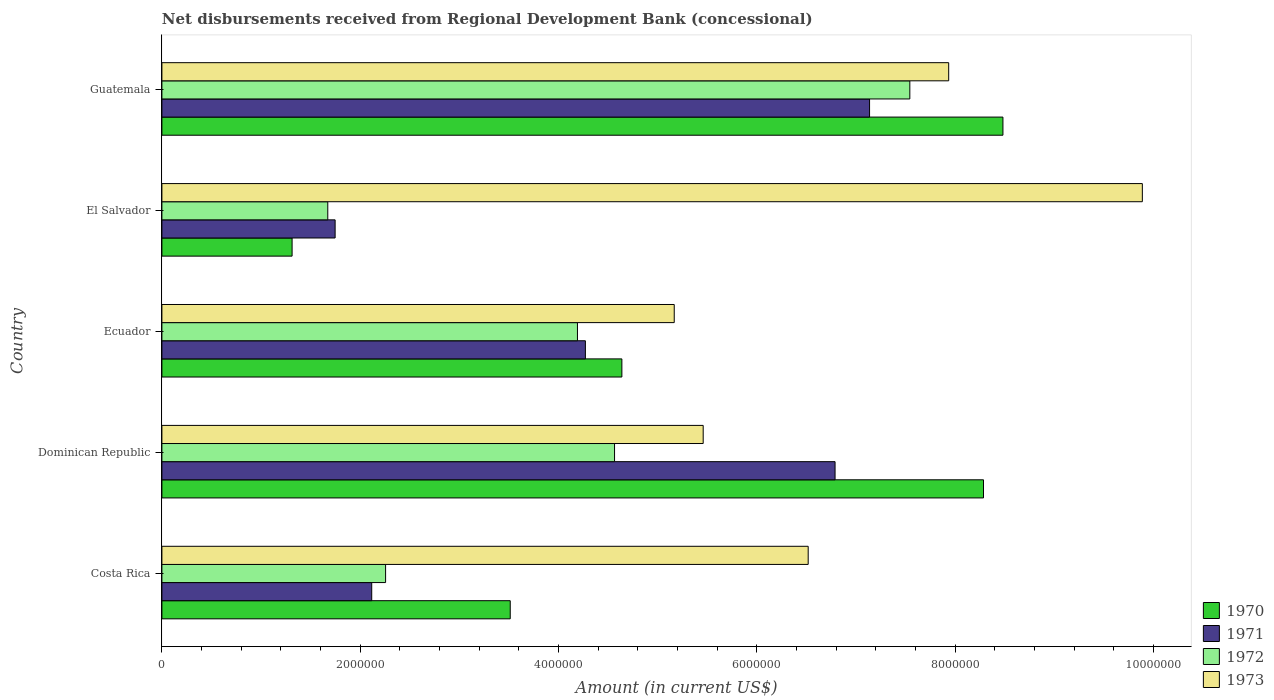Are the number of bars per tick equal to the number of legend labels?
Your response must be concise. Yes. Are the number of bars on each tick of the Y-axis equal?
Provide a short and direct response. Yes. What is the label of the 3rd group of bars from the top?
Offer a terse response. Ecuador. In how many cases, is the number of bars for a given country not equal to the number of legend labels?
Give a very brief answer. 0. What is the amount of disbursements received from Regional Development Bank in 1970 in El Salvador?
Your response must be concise. 1.31e+06. Across all countries, what is the maximum amount of disbursements received from Regional Development Bank in 1972?
Offer a very short reply. 7.54e+06. Across all countries, what is the minimum amount of disbursements received from Regional Development Bank in 1972?
Provide a short and direct response. 1.67e+06. In which country was the amount of disbursements received from Regional Development Bank in 1973 maximum?
Your answer should be very brief. El Salvador. In which country was the amount of disbursements received from Regional Development Bank in 1970 minimum?
Provide a succinct answer. El Salvador. What is the total amount of disbursements received from Regional Development Bank in 1972 in the graph?
Give a very brief answer. 2.02e+07. What is the difference between the amount of disbursements received from Regional Development Bank in 1973 in Ecuador and that in Guatemala?
Offer a very short reply. -2.77e+06. What is the difference between the amount of disbursements received from Regional Development Bank in 1973 in El Salvador and the amount of disbursements received from Regional Development Bank in 1972 in Ecuador?
Offer a very short reply. 5.70e+06. What is the average amount of disbursements received from Regional Development Bank in 1970 per country?
Your response must be concise. 5.25e+06. What is the difference between the amount of disbursements received from Regional Development Bank in 1970 and amount of disbursements received from Regional Development Bank in 1973 in Guatemala?
Give a very brief answer. 5.47e+05. In how many countries, is the amount of disbursements received from Regional Development Bank in 1973 greater than 4000000 US$?
Your answer should be very brief. 5. What is the ratio of the amount of disbursements received from Regional Development Bank in 1970 in Ecuador to that in El Salvador?
Give a very brief answer. 3.53. Is the amount of disbursements received from Regional Development Bank in 1971 in El Salvador less than that in Guatemala?
Ensure brevity in your answer.  Yes. Is the difference between the amount of disbursements received from Regional Development Bank in 1970 in Costa Rica and Dominican Republic greater than the difference between the amount of disbursements received from Regional Development Bank in 1973 in Costa Rica and Dominican Republic?
Keep it short and to the point. No. What is the difference between the highest and the second highest amount of disbursements received from Regional Development Bank in 1973?
Offer a terse response. 1.95e+06. What is the difference between the highest and the lowest amount of disbursements received from Regional Development Bank in 1971?
Offer a terse response. 5.39e+06. In how many countries, is the amount of disbursements received from Regional Development Bank in 1970 greater than the average amount of disbursements received from Regional Development Bank in 1970 taken over all countries?
Make the answer very short. 2. Is the sum of the amount of disbursements received from Regional Development Bank in 1973 in Costa Rica and Guatemala greater than the maximum amount of disbursements received from Regional Development Bank in 1972 across all countries?
Give a very brief answer. Yes. What does the 1st bar from the top in Guatemala represents?
Your answer should be compact. 1973. Are all the bars in the graph horizontal?
Ensure brevity in your answer.  Yes. How many countries are there in the graph?
Offer a terse response. 5. Does the graph contain any zero values?
Your response must be concise. No. Does the graph contain grids?
Keep it short and to the point. No. How many legend labels are there?
Provide a short and direct response. 4. What is the title of the graph?
Give a very brief answer. Net disbursements received from Regional Development Bank (concessional). What is the label or title of the X-axis?
Provide a succinct answer. Amount (in current US$). What is the Amount (in current US$) of 1970 in Costa Rica?
Provide a succinct answer. 3.51e+06. What is the Amount (in current US$) of 1971 in Costa Rica?
Your answer should be compact. 2.12e+06. What is the Amount (in current US$) of 1972 in Costa Rica?
Your answer should be very brief. 2.26e+06. What is the Amount (in current US$) of 1973 in Costa Rica?
Provide a short and direct response. 6.52e+06. What is the Amount (in current US$) in 1970 in Dominican Republic?
Offer a terse response. 8.29e+06. What is the Amount (in current US$) in 1971 in Dominican Republic?
Make the answer very short. 6.79e+06. What is the Amount (in current US$) in 1972 in Dominican Republic?
Give a very brief answer. 4.56e+06. What is the Amount (in current US$) of 1973 in Dominican Republic?
Make the answer very short. 5.46e+06. What is the Amount (in current US$) of 1970 in Ecuador?
Provide a succinct answer. 4.64e+06. What is the Amount (in current US$) in 1971 in Ecuador?
Make the answer very short. 4.27e+06. What is the Amount (in current US$) in 1972 in Ecuador?
Your answer should be compact. 4.19e+06. What is the Amount (in current US$) in 1973 in Ecuador?
Ensure brevity in your answer.  5.17e+06. What is the Amount (in current US$) in 1970 in El Salvador?
Your answer should be compact. 1.31e+06. What is the Amount (in current US$) of 1971 in El Salvador?
Offer a terse response. 1.75e+06. What is the Amount (in current US$) in 1972 in El Salvador?
Offer a terse response. 1.67e+06. What is the Amount (in current US$) of 1973 in El Salvador?
Your answer should be compact. 9.89e+06. What is the Amount (in current US$) in 1970 in Guatemala?
Ensure brevity in your answer.  8.48e+06. What is the Amount (in current US$) of 1971 in Guatemala?
Ensure brevity in your answer.  7.14e+06. What is the Amount (in current US$) in 1972 in Guatemala?
Your response must be concise. 7.54e+06. What is the Amount (in current US$) in 1973 in Guatemala?
Ensure brevity in your answer.  7.94e+06. Across all countries, what is the maximum Amount (in current US$) of 1970?
Provide a short and direct response. 8.48e+06. Across all countries, what is the maximum Amount (in current US$) in 1971?
Your answer should be very brief. 7.14e+06. Across all countries, what is the maximum Amount (in current US$) of 1972?
Ensure brevity in your answer.  7.54e+06. Across all countries, what is the maximum Amount (in current US$) of 1973?
Your answer should be very brief. 9.89e+06. Across all countries, what is the minimum Amount (in current US$) in 1970?
Your answer should be compact. 1.31e+06. Across all countries, what is the minimum Amount (in current US$) in 1971?
Provide a succinct answer. 1.75e+06. Across all countries, what is the minimum Amount (in current US$) in 1972?
Make the answer very short. 1.67e+06. Across all countries, what is the minimum Amount (in current US$) of 1973?
Provide a short and direct response. 5.17e+06. What is the total Amount (in current US$) of 1970 in the graph?
Provide a short and direct response. 2.62e+07. What is the total Amount (in current US$) of 1971 in the graph?
Keep it short and to the point. 2.21e+07. What is the total Amount (in current US$) of 1972 in the graph?
Your answer should be very brief. 2.02e+07. What is the total Amount (in current US$) in 1973 in the graph?
Offer a very short reply. 3.50e+07. What is the difference between the Amount (in current US$) of 1970 in Costa Rica and that in Dominican Republic?
Ensure brevity in your answer.  -4.77e+06. What is the difference between the Amount (in current US$) in 1971 in Costa Rica and that in Dominican Republic?
Your answer should be compact. -4.67e+06. What is the difference between the Amount (in current US$) of 1972 in Costa Rica and that in Dominican Republic?
Offer a terse response. -2.31e+06. What is the difference between the Amount (in current US$) in 1973 in Costa Rica and that in Dominican Republic?
Offer a very short reply. 1.06e+06. What is the difference between the Amount (in current US$) of 1970 in Costa Rica and that in Ecuador?
Your response must be concise. -1.13e+06. What is the difference between the Amount (in current US$) in 1971 in Costa Rica and that in Ecuador?
Your answer should be very brief. -2.16e+06. What is the difference between the Amount (in current US$) of 1972 in Costa Rica and that in Ecuador?
Make the answer very short. -1.94e+06. What is the difference between the Amount (in current US$) of 1973 in Costa Rica and that in Ecuador?
Keep it short and to the point. 1.35e+06. What is the difference between the Amount (in current US$) of 1970 in Costa Rica and that in El Salvador?
Offer a very short reply. 2.20e+06. What is the difference between the Amount (in current US$) in 1971 in Costa Rica and that in El Salvador?
Your answer should be very brief. 3.69e+05. What is the difference between the Amount (in current US$) in 1972 in Costa Rica and that in El Salvador?
Your answer should be compact. 5.83e+05. What is the difference between the Amount (in current US$) in 1973 in Costa Rica and that in El Salvador?
Provide a succinct answer. -3.37e+06. What is the difference between the Amount (in current US$) of 1970 in Costa Rica and that in Guatemala?
Your response must be concise. -4.97e+06. What is the difference between the Amount (in current US$) in 1971 in Costa Rica and that in Guatemala?
Your answer should be very brief. -5.02e+06. What is the difference between the Amount (in current US$) of 1972 in Costa Rica and that in Guatemala?
Offer a terse response. -5.29e+06. What is the difference between the Amount (in current US$) in 1973 in Costa Rica and that in Guatemala?
Offer a very short reply. -1.42e+06. What is the difference between the Amount (in current US$) of 1970 in Dominican Republic and that in Ecuador?
Make the answer very short. 3.65e+06. What is the difference between the Amount (in current US$) of 1971 in Dominican Republic and that in Ecuador?
Ensure brevity in your answer.  2.52e+06. What is the difference between the Amount (in current US$) of 1972 in Dominican Republic and that in Ecuador?
Provide a succinct answer. 3.74e+05. What is the difference between the Amount (in current US$) of 1973 in Dominican Republic and that in Ecuador?
Provide a succinct answer. 2.92e+05. What is the difference between the Amount (in current US$) in 1970 in Dominican Republic and that in El Salvador?
Keep it short and to the point. 6.97e+06. What is the difference between the Amount (in current US$) in 1971 in Dominican Republic and that in El Salvador?
Your answer should be compact. 5.04e+06. What is the difference between the Amount (in current US$) in 1972 in Dominican Republic and that in El Salvador?
Make the answer very short. 2.89e+06. What is the difference between the Amount (in current US$) in 1973 in Dominican Republic and that in El Salvador?
Your answer should be compact. -4.43e+06. What is the difference between the Amount (in current US$) of 1970 in Dominican Republic and that in Guatemala?
Give a very brief answer. -1.96e+05. What is the difference between the Amount (in current US$) of 1971 in Dominican Republic and that in Guatemala?
Make the answer very short. -3.48e+05. What is the difference between the Amount (in current US$) in 1972 in Dominican Republic and that in Guatemala?
Offer a terse response. -2.98e+06. What is the difference between the Amount (in current US$) in 1973 in Dominican Republic and that in Guatemala?
Ensure brevity in your answer.  -2.48e+06. What is the difference between the Amount (in current US$) of 1970 in Ecuador and that in El Salvador?
Keep it short and to the point. 3.33e+06. What is the difference between the Amount (in current US$) in 1971 in Ecuador and that in El Salvador?
Offer a very short reply. 2.52e+06. What is the difference between the Amount (in current US$) in 1972 in Ecuador and that in El Salvador?
Make the answer very short. 2.52e+06. What is the difference between the Amount (in current US$) in 1973 in Ecuador and that in El Salvador?
Provide a succinct answer. -4.72e+06. What is the difference between the Amount (in current US$) of 1970 in Ecuador and that in Guatemala?
Your answer should be very brief. -3.84e+06. What is the difference between the Amount (in current US$) of 1971 in Ecuador and that in Guatemala?
Provide a succinct answer. -2.87e+06. What is the difference between the Amount (in current US$) of 1972 in Ecuador and that in Guatemala?
Ensure brevity in your answer.  -3.35e+06. What is the difference between the Amount (in current US$) of 1973 in Ecuador and that in Guatemala?
Ensure brevity in your answer.  -2.77e+06. What is the difference between the Amount (in current US$) of 1970 in El Salvador and that in Guatemala?
Provide a short and direct response. -7.17e+06. What is the difference between the Amount (in current US$) in 1971 in El Salvador and that in Guatemala?
Your answer should be compact. -5.39e+06. What is the difference between the Amount (in current US$) in 1972 in El Salvador and that in Guatemala?
Offer a terse response. -5.87e+06. What is the difference between the Amount (in current US$) of 1973 in El Salvador and that in Guatemala?
Provide a succinct answer. 1.95e+06. What is the difference between the Amount (in current US$) of 1970 in Costa Rica and the Amount (in current US$) of 1971 in Dominican Republic?
Provide a succinct answer. -3.28e+06. What is the difference between the Amount (in current US$) of 1970 in Costa Rica and the Amount (in current US$) of 1972 in Dominican Republic?
Make the answer very short. -1.05e+06. What is the difference between the Amount (in current US$) in 1970 in Costa Rica and the Amount (in current US$) in 1973 in Dominican Republic?
Keep it short and to the point. -1.95e+06. What is the difference between the Amount (in current US$) in 1971 in Costa Rica and the Amount (in current US$) in 1972 in Dominican Republic?
Make the answer very short. -2.45e+06. What is the difference between the Amount (in current US$) in 1971 in Costa Rica and the Amount (in current US$) in 1973 in Dominican Republic?
Provide a succinct answer. -3.34e+06. What is the difference between the Amount (in current US$) in 1972 in Costa Rica and the Amount (in current US$) in 1973 in Dominican Republic?
Your answer should be compact. -3.20e+06. What is the difference between the Amount (in current US$) of 1970 in Costa Rica and the Amount (in current US$) of 1971 in Ecuador?
Your response must be concise. -7.58e+05. What is the difference between the Amount (in current US$) in 1970 in Costa Rica and the Amount (in current US$) in 1972 in Ecuador?
Offer a terse response. -6.78e+05. What is the difference between the Amount (in current US$) in 1970 in Costa Rica and the Amount (in current US$) in 1973 in Ecuador?
Your answer should be compact. -1.65e+06. What is the difference between the Amount (in current US$) of 1971 in Costa Rica and the Amount (in current US$) of 1972 in Ecuador?
Your response must be concise. -2.08e+06. What is the difference between the Amount (in current US$) in 1971 in Costa Rica and the Amount (in current US$) in 1973 in Ecuador?
Offer a very short reply. -3.05e+06. What is the difference between the Amount (in current US$) of 1972 in Costa Rica and the Amount (in current US$) of 1973 in Ecuador?
Provide a succinct answer. -2.91e+06. What is the difference between the Amount (in current US$) of 1970 in Costa Rica and the Amount (in current US$) of 1971 in El Salvador?
Provide a succinct answer. 1.77e+06. What is the difference between the Amount (in current US$) of 1970 in Costa Rica and the Amount (in current US$) of 1972 in El Salvador?
Provide a short and direct response. 1.84e+06. What is the difference between the Amount (in current US$) of 1970 in Costa Rica and the Amount (in current US$) of 1973 in El Salvador?
Keep it short and to the point. -6.38e+06. What is the difference between the Amount (in current US$) in 1971 in Costa Rica and the Amount (in current US$) in 1972 in El Salvador?
Ensure brevity in your answer.  4.43e+05. What is the difference between the Amount (in current US$) in 1971 in Costa Rica and the Amount (in current US$) in 1973 in El Salvador?
Your response must be concise. -7.77e+06. What is the difference between the Amount (in current US$) in 1972 in Costa Rica and the Amount (in current US$) in 1973 in El Salvador?
Give a very brief answer. -7.63e+06. What is the difference between the Amount (in current US$) in 1970 in Costa Rica and the Amount (in current US$) in 1971 in Guatemala?
Offer a very short reply. -3.62e+06. What is the difference between the Amount (in current US$) of 1970 in Costa Rica and the Amount (in current US$) of 1972 in Guatemala?
Offer a terse response. -4.03e+06. What is the difference between the Amount (in current US$) of 1970 in Costa Rica and the Amount (in current US$) of 1973 in Guatemala?
Your answer should be compact. -4.42e+06. What is the difference between the Amount (in current US$) of 1971 in Costa Rica and the Amount (in current US$) of 1972 in Guatemala?
Keep it short and to the point. -5.43e+06. What is the difference between the Amount (in current US$) in 1971 in Costa Rica and the Amount (in current US$) in 1973 in Guatemala?
Your answer should be compact. -5.82e+06. What is the difference between the Amount (in current US$) in 1972 in Costa Rica and the Amount (in current US$) in 1973 in Guatemala?
Offer a very short reply. -5.68e+06. What is the difference between the Amount (in current US$) of 1970 in Dominican Republic and the Amount (in current US$) of 1971 in Ecuador?
Provide a succinct answer. 4.02e+06. What is the difference between the Amount (in current US$) in 1970 in Dominican Republic and the Amount (in current US$) in 1972 in Ecuador?
Make the answer very short. 4.10e+06. What is the difference between the Amount (in current US$) in 1970 in Dominican Republic and the Amount (in current US$) in 1973 in Ecuador?
Offer a terse response. 3.12e+06. What is the difference between the Amount (in current US$) in 1971 in Dominican Republic and the Amount (in current US$) in 1972 in Ecuador?
Keep it short and to the point. 2.60e+06. What is the difference between the Amount (in current US$) of 1971 in Dominican Republic and the Amount (in current US$) of 1973 in Ecuador?
Offer a terse response. 1.62e+06. What is the difference between the Amount (in current US$) of 1972 in Dominican Republic and the Amount (in current US$) of 1973 in Ecuador?
Ensure brevity in your answer.  -6.02e+05. What is the difference between the Amount (in current US$) of 1970 in Dominican Republic and the Amount (in current US$) of 1971 in El Salvador?
Make the answer very short. 6.54e+06. What is the difference between the Amount (in current US$) in 1970 in Dominican Republic and the Amount (in current US$) in 1972 in El Salvador?
Provide a short and direct response. 6.61e+06. What is the difference between the Amount (in current US$) of 1970 in Dominican Republic and the Amount (in current US$) of 1973 in El Salvador?
Your response must be concise. -1.60e+06. What is the difference between the Amount (in current US$) of 1971 in Dominican Republic and the Amount (in current US$) of 1972 in El Salvador?
Keep it short and to the point. 5.12e+06. What is the difference between the Amount (in current US$) of 1971 in Dominican Republic and the Amount (in current US$) of 1973 in El Salvador?
Give a very brief answer. -3.10e+06. What is the difference between the Amount (in current US$) in 1972 in Dominican Republic and the Amount (in current US$) in 1973 in El Salvador?
Give a very brief answer. -5.32e+06. What is the difference between the Amount (in current US$) of 1970 in Dominican Republic and the Amount (in current US$) of 1971 in Guatemala?
Give a very brief answer. 1.15e+06. What is the difference between the Amount (in current US$) in 1970 in Dominican Republic and the Amount (in current US$) in 1972 in Guatemala?
Keep it short and to the point. 7.43e+05. What is the difference between the Amount (in current US$) in 1970 in Dominican Republic and the Amount (in current US$) in 1973 in Guatemala?
Offer a terse response. 3.51e+05. What is the difference between the Amount (in current US$) in 1971 in Dominican Republic and the Amount (in current US$) in 1972 in Guatemala?
Make the answer very short. -7.54e+05. What is the difference between the Amount (in current US$) in 1971 in Dominican Republic and the Amount (in current US$) in 1973 in Guatemala?
Offer a terse response. -1.15e+06. What is the difference between the Amount (in current US$) in 1972 in Dominican Republic and the Amount (in current US$) in 1973 in Guatemala?
Your answer should be compact. -3.37e+06. What is the difference between the Amount (in current US$) of 1970 in Ecuador and the Amount (in current US$) of 1971 in El Salvador?
Your response must be concise. 2.89e+06. What is the difference between the Amount (in current US$) of 1970 in Ecuador and the Amount (in current US$) of 1972 in El Salvador?
Your response must be concise. 2.97e+06. What is the difference between the Amount (in current US$) of 1970 in Ecuador and the Amount (in current US$) of 1973 in El Salvador?
Offer a terse response. -5.25e+06. What is the difference between the Amount (in current US$) in 1971 in Ecuador and the Amount (in current US$) in 1972 in El Salvador?
Keep it short and to the point. 2.60e+06. What is the difference between the Amount (in current US$) in 1971 in Ecuador and the Amount (in current US$) in 1973 in El Salvador?
Your response must be concise. -5.62e+06. What is the difference between the Amount (in current US$) of 1972 in Ecuador and the Amount (in current US$) of 1973 in El Salvador?
Your answer should be compact. -5.70e+06. What is the difference between the Amount (in current US$) of 1970 in Ecuador and the Amount (in current US$) of 1971 in Guatemala?
Make the answer very short. -2.50e+06. What is the difference between the Amount (in current US$) of 1970 in Ecuador and the Amount (in current US$) of 1972 in Guatemala?
Keep it short and to the point. -2.90e+06. What is the difference between the Amount (in current US$) of 1970 in Ecuador and the Amount (in current US$) of 1973 in Guatemala?
Provide a short and direct response. -3.30e+06. What is the difference between the Amount (in current US$) in 1971 in Ecuador and the Amount (in current US$) in 1972 in Guatemala?
Your answer should be compact. -3.27e+06. What is the difference between the Amount (in current US$) in 1971 in Ecuador and the Amount (in current US$) in 1973 in Guatemala?
Give a very brief answer. -3.66e+06. What is the difference between the Amount (in current US$) in 1972 in Ecuador and the Amount (in current US$) in 1973 in Guatemala?
Your answer should be very brief. -3.74e+06. What is the difference between the Amount (in current US$) of 1970 in El Salvador and the Amount (in current US$) of 1971 in Guatemala?
Offer a terse response. -5.82e+06. What is the difference between the Amount (in current US$) of 1970 in El Salvador and the Amount (in current US$) of 1972 in Guatemala?
Your answer should be compact. -6.23e+06. What is the difference between the Amount (in current US$) in 1970 in El Salvador and the Amount (in current US$) in 1973 in Guatemala?
Your response must be concise. -6.62e+06. What is the difference between the Amount (in current US$) of 1971 in El Salvador and the Amount (in current US$) of 1972 in Guatemala?
Your response must be concise. -5.80e+06. What is the difference between the Amount (in current US$) of 1971 in El Salvador and the Amount (in current US$) of 1973 in Guatemala?
Make the answer very short. -6.19e+06. What is the difference between the Amount (in current US$) in 1972 in El Salvador and the Amount (in current US$) in 1973 in Guatemala?
Provide a short and direct response. -6.26e+06. What is the average Amount (in current US$) of 1970 per country?
Provide a succinct answer. 5.25e+06. What is the average Amount (in current US$) of 1971 per country?
Your answer should be compact. 4.41e+06. What is the average Amount (in current US$) in 1972 per country?
Offer a very short reply. 4.05e+06. What is the average Amount (in current US$) of 1973 per country?
Keep it short and to the point. 6.99e+06. What is the difference between the Amount (in current US$) of 1970 and Amount (in current US$) of 1971 in Costa Rica?
Provide a short and direct response. 1.40e+06. What is the difference between the Amount (in current US$) of 1970 and Amount (in current US$) of 1972 in Costa Rica?
Keep it short and to the point. 1.26e+06. What is the difference between the Amount (in current US$) of 1970 and Amount (in current US$) of 1973 in Costa Rica?
Your response must be concise. -3.00e+06. What is the difference between the Amount (in current US$) in 1971 and Amount (in current US$) in 1972 in Costa Rica?
Your response must be concise. -1.40e+05. What is the difference between the Amount (in current US$) of 1971 and Amount (in current US$) of 1973 in Costa Rica?
Keep it short and to the point. -4.40e+06. What is the difference between the Amount (in current US$) in 1972 and Amount (in current US$) in 1973 in Costa Rica?
Offer a very short reply. -4.26e+06. What is the difference between the Amount (in current US$) in 1970 and Amount (in current US$) in 1971 in Dominican Republic?
Your answer should be very brief. 1.50e+06. What is the difference between the Amount (in current US$) of 1970 and Amount (in current US$) of 1972 in Dominican Republic?
Give a very brief answer. 3.72e+06. What is the difference between the Amount (in current US$) of 1970 and Amount (in current US$) of 1973 in Dominican Republic?
Make the answer very short. 2.83e+06. What is the difference between the Amount (in current US$) in 1971 and Amount (in current US$) in 1972 in Dominican Republic?
Offer a very short reply. 2.22e+06. What is the difference between the Amount (in current US$) of 1971 and Amount (in current US$) of 1973 in Dominican Republic?
Keep it short and to the point. 1.33e+06. What is the difference between the Amount (in current US$) in 1972 and Amount (in current US$) in 1973 in Dominican Republic?
Your answer should be compact. -8.94e+05. What is the difference between the Amount (in current US$) in 1970 and Amount (in current US$) in 1971 in Ecuador?
Keep it short and to the point. 3.68e+05. What is the difference between the Amount (in current US$) of 1970 and Amount (in current US$) of 1972 in Ecuador?
Offer a terse response. 4.48e+05. What is the difference between the Amount (in current US$) of 1970 and Amount (in current US$) of 1973 in Ecuador?
Give a very brief answer. -5.28e+05. What is the difference between the Amount (in current US$) in 1971 and Amount (in current US$) in 1973 in Ecuador?
Offer a very short reply. -8.96e+05. What is the difference between the Amount (in current US$) of 1972 and Amount (in current US$) of 1973 in Ecuador?
Offer a very short reply. -9.76e+05. What is the difference between the Amount (in current US$) in 1970 and Amount (in current US$) in 1971 in El Salvador?
Give a very brief answer. -4.34e+05. What is the difference between the Amount (in current US$) of 1970 and Amount (in current US$) of 1972 in El Salvador?
Offer a very short reply. -3.60e+05. What is the difference between the Amount (in current US$) in 1970 and Amount (in current US$) in 1973 in El Salvador?
Make the answer very short. -8.58e+06. What is the difference between the Amount (in current US$) of 1971 and Amount (in current US$) of 1972 in El Salvador?
Make the answer very short. 7.40e+04. What is the difference between the Amount (in current US$) in 1971 and Amount (in current US$) in 1973 in El Salvador?
Offer a terse response. -8.14e+06. What is the difference between the Amount (in current US$) of 1972 and Amount (in current US$) of 1973 in El Salvador?
Ensure brevity in your answer.  -8.22e+06. What is the difference between the Amount (in current US$) of 1970 and Amount (in current US$) of 1971 in Guatemala?
Ensure brevity in your answer.  1.34e+06. What is the difference between the Amount (in current US$) in 1970 and Amount (in current US$) in 1972 in Guatemala?
Offer a very short reply. 9.39e+05. What is the difference between the Amount (in current US$) in 1970 and Amount (in current US$) in 1973 in Guatemala?
Ensure brevity in your answer.  5.47e+05. What is the difference between the Amount (in current US$) in 1971 and Amount (in current US$) in 1972 in Guatemala?
Offer a very short reply. -4.06e+05. What is the difference between the Amount (in current US$) in 1971 and Amount (in current US$) in 1973 in Guatemala?
Provide a short and direct response. -7.98e+05. What is the difference between the Amount (in current US$) of 1972 and Amount (in current US$) of 1973 in Guatemala?
Provide a succinct answer. -3.92e+05. What is the ratio of the Amount (in current US$) of 1970 in Costa Rica to that in Dominican Republic?
Offer a terse response. 0.42. What is the ratio of the Amount (in current US$) in 1971 in Costa Rica to that in Dominican Republic?
Offer a terse response. 0.31. What is the ratio of the Amount (in current US$) in 1972 in Costa Rica to that in Dominican Republic?
Make the answer very short. 0.49. What is the ratio of the Amount (in current US$) of 1973 in Costa Rica to that in Dominican Republic?
Offer a very short reply. 1.19. What is the ratio of the Amount (in current US$) of 1970 in Costa Rica to that in Ecuador?
Offer a very short reply. 0.76. What is the ratio of the Amount (in current US$) in 1971 in Costa Rica to that in Ecuador?
Your answer should be compact. 0.5. What is the ratio of the Amount (in current US$) of 1972 in Costa Rica to that in Ecuador?
Give a very brief answer. 0.54. What is the ratio of the Amount (in current US$) in 1973 in Costa Rica to that in Ecuador?
Make the answer very short. 1.26. What is the ratio of the Amount (in current US$) in 1970 in Costa Rica to that in El Salvador?
Keep it short and to the point. 2.68. What is the ratio of the Amount (in current US$) of 1971 in Costa Rica to that in El Salvador?
Your answer should be compact. 1.21. What is the ratio of the Amount (in current US$) of 1972 in Costa Rica to that in El Salvador?
Your response must be concise. 1.35. What is the ratio of the Amount (in current US$) in 1973 in Costa Rica to that in El Salvador?
Offer a very short reply. 0.66. What is the ratio of the Amount (in current US$) of 1970 in Costa Rica to that in Guatemala?
Give a very brief answer. 0.41. What is the ratio of the Amount (in current US$) in 1971 in Costa Rica to that in Guatemala?
Your response must be concise. 0.3. What is the ratio of the Amount (in current US$) of 1972 in Costa Rica to that in Guatemala?
Your response must be concise. 0.3. What is the ratio of the Amount (in current US$) of 1973 in Costa Rica to that in Guatemala?
Your answer should be very brief. 0.82. What is the ratio of the Amount (in current US$) in 1970 in Dominican Republic to that in Ecuador?
Give a very brief answer. 1.79. What is the ratio of the Amount (in current US$) in 1971 in Dominican Republic to that in Ecuador?
Your answer should be very brief. 1.59. What is the ratio of the Amount (in current US$) in 1972 in Dominican Republic to that in Ecuador?
Ensure brevity in your answer.  1.09. What is the ratio of the Amount (in current US$) of 1973 in Dominican Republic to that in Ecuador?
Offer a very short reply. 1.06. What is the ratio of the Amount (in current US$) of 1970 in Dominican Republic to that in El Salvador?
Make the answer very short. 6.31. What is the ratio of the Amount (in current US$) of 1971 in Dominican Republic to that in El Salvador?
Keep it short and to the point. 3.89. What is the ratio of the Amount (in current US$) of 1972 in Dominican Republic to that in El Salvador?
Your answer should be compact. 2.73. What is the ratio of the Amount (in current US$) of 1973 in Dominican Republic to that in El Salvador?
Provide a succinct answer. 0.55. What is the ratio of the Amount (in current US$) in 1970 in Dominican Republic to that in Guatemala?
Your answer should be compact. 0.98. What is the ratio of the Amount (in current US$) of 1971 in Dominican Republic to that in Guatemala?
Your answer should be compact. 0.95. What is the ratio of the Amount (in current US$) of 1972 in Dominican Republic to that in Guatemala?
Keep it short and to the point. 0.61. What is the ratio of the Amount (in current US$) of 1973 in Dominican Republic to that in Guatemala?
Ensure brevity in your answer.  0.69. What is the ratio of the Amount (in current US$) of 1970 in Ecuador to that in El Salvador?
Your answer should be very brief. 3.53. What is the ratio of the Amount (in current US$) of 1971 in Ecuador to that in El Salvador?
Provide a short and direct response. 2.44. What is the ratio of the Amount (in current US$) of 1972 in Ecuador to that in El Salvador?
Your answer should be very brief. 2.51. What is the ratio of the Amount (in current US$) in 1973 in Ecuador to that in El Salvador?
Offer a very short reply. 0.52. What is the ratio of the Amount (in current US$) in 1970 in Ecuador to that in Guatemala?
Your response must be concise. 0.55. What is the ratio of the Amount (in current US$) of 1971 in Ecuador to that in Guatemala?
Your answer should be compact. 0.6. What is the ratio of the Amount (in current US$) in 1972 in Ecuador to that in Guatemala?
Provide a short and direct response. 0.56. What is the ratio of the Amount (in current US$) in 1973 in Ecuador to that in Guatemala?
Your answer should be compact. 0.65. What is the ratio of the Amount (in current US$) of 1970 in El Salvador to that in Guatemala?
Your answer should be very brief. 0.15. What is the ratio of the Amount (in current US$) in 1971 in El Salvador to that in Guatemala?
Offer a terse response. 0.24. What is the ratio of the Amount (in current US$) in 1972 in El Salvador to that in Guatemala?
Offer a terse response. 0.22. What is the ratio of the Amount (in current US$) of 1973 in El Salvador to that in Guatemala?
Your response must be concise. 1.25. What is the difference between the highest and the second highest Amount (in current US$) of 1970?
Ensure brevity in your answer.  1.96e+05. What is the difference between the highest and the second highest Amount (in current US$) in 1971?
Your response must be concise. 3.48e+05. What is the difference between the highest and the second highest Amount (in current US$) of 1972?
Your answer should be very brief. 2.98e+06. What is the difference between the highest and the second highest Amount (in current US$) in 1973?
Offer a very short reply. 1.95e+06. What is the difference between the highest and the lowest Amount (in current US$) in 1970?
Your answer should be very brief. 7.17e+06. What is the difference between the highest and the lowest Amount (in current US$) in 1971?
Provide a short and direct response. 5.39e+06. What is the difference between the highest and the lowest Amount (in current US$) in 1972?
Provide a short and direct response. 5.87e+06. What is the difference between the highest and the lowest Amount (in current US$) of 1973?
Your answer should be very brief. 4.72e+06. 